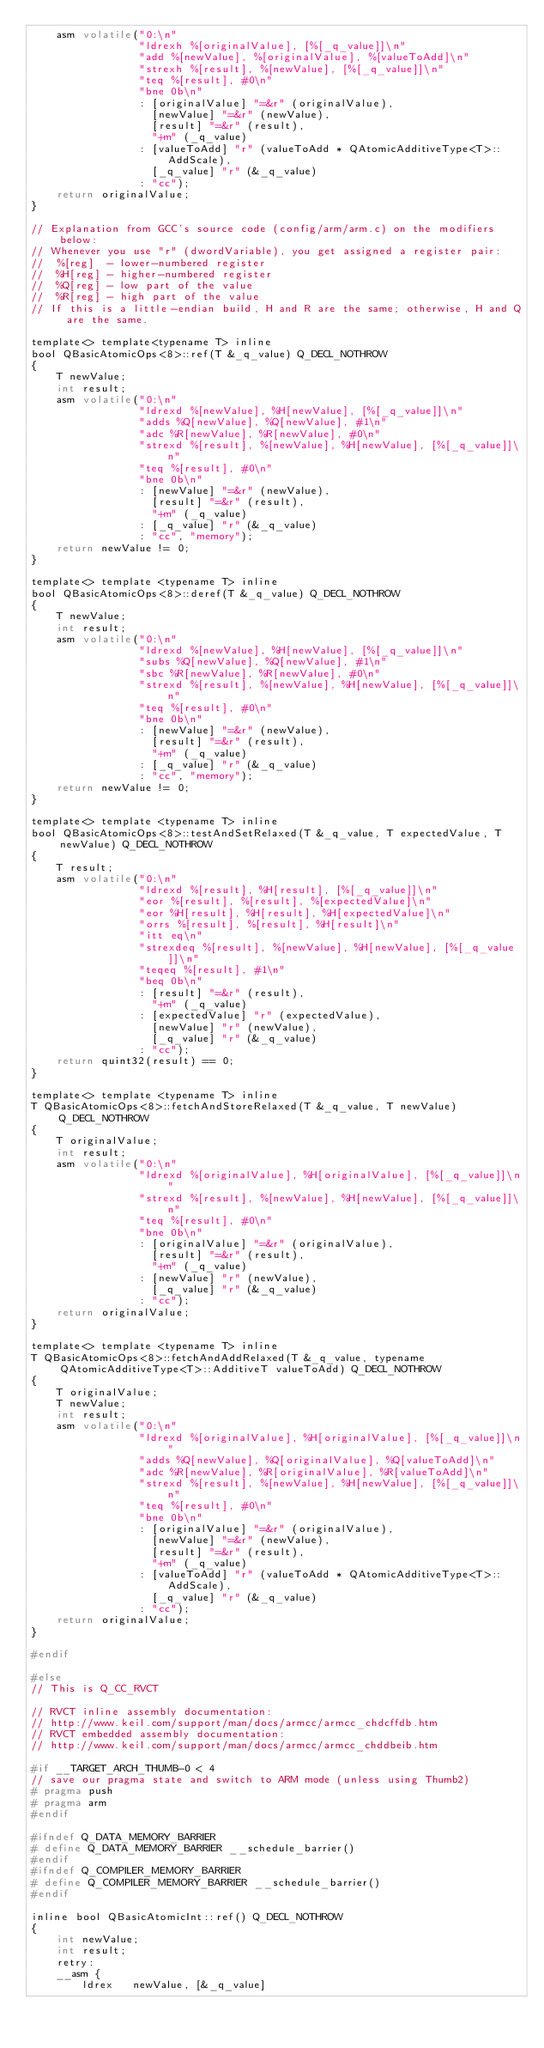Convert code to text. <code><loc_0><loc_0><loc_500><loc_500><_C_>    asm volatile("0:\n"
                 "ldrexh %[originalValue], [%[_q_value]]\n"
                 "add %[newValue], %[originalValue], %[valueToAdd]\n"
                 "strexh %[result], %[newValue], [%[_q_value]]\n"
                 "teq %[result], #0\n"
                 "bne 0b\n"
                 : [originalValue] "=&r" (originalValue),
                   [newValue] "=&r" (newValue),
                   [result] "=&r" (result),
                   "+m" (_q_value)
                 : [valueToAdd] "r" (valueToAdd * QAtomicAdditiveType<T>::AddScale),
                   [_q_value] "r" (&_q_value)
                 : "cc");
    return originalValue;
}

// Explanation from GCC's source code (config/arm/arm.c) on the modifiers below:
// Whenever you use "r" (dwordVariable), you get assigned a register pair:
//  %[reg]  - lower-numbered register
//  %H[reg] - higher-numbered register
//  %Q[reg] - low part of the value
//  %R[reg] - high part of the value
// If this is a little-endian build, H and R are the same; otherwise, H and Q are the same.

template<> template<typename T> inline
bool QBasicAtomicOps<8>::ref(T &_q_value) Q_DECL_NOTHROW
{
    T newValue;
    int result;
    asm volatile("0:\n"
                 "ldrexd %[newValue], %H[newValue], [%[_q_value]]\n"
                 "adds %Q[newValue], %Q[newValue], #1\n"
                 "adc %R[newValue], %R[newValue], #0\n"
                 "strexd %[result], %[newValue], %H[newValue], [%[_q_value]]\n"
                 "teq %[result], #0\n"
                 "bne 0b\n"
                 : [newValue] "=&r" (newValue),
                   [result] "=&r" (result),
                   "+m" (_q_value)
                 : [_q_value] "r" (&_q_value)
                 : "cc", "memory");
    return newValue != 0;
}

template<> template <typename T> inline
bool QBasicAtomicOps<8>::deref(T &_q_value) Q_DECL_NOTHROW
{
    T newValue;
    int result;
    asm volatile("0:\n"
                 "ldrexd %[newValue], %H[newValue], [%[_q_value]]\n"
                 "subs %Q[newValue], %Q[newValue], #1\n"
                 "sbc %R[newValue], %R[newValue], #0\n"
                 "strexd %[result], %[newValue], %H[newValue], [%[_q_value]]\n"
                 "teq %[result], #0\n"
                 "bne 0b\n"
                 : [newValue] "=&r" (newValue),
                   [result] "=&r" (result),
                   "+m" (_q_value)
                 : [_q_value] "r" (&_q_value)
                 : "cc", "memory");
    return newValue != 0;
}

template<> template <typename T> inline
bool QBasicAtomicOps<8>::testAndSetRelaxed(T &_q_value, T expectedValue, T newValue) Q_DECL_NOTHROW
{
    T result;
    asm volatile("0:\n"
                 "ldrexd %[result], %H[result], [%[_q_value]]\n"
                 "eor %[result], %[result], %[expectedValue]\n"
                 "eor %H[result], %H[result], %H[expectedValue]\n"
                 "orrs %[result], %[result], %H[result]\n"
                 "itt eq\n"
                 "strexdeq %[result], %[newValue], %H[newValue], [%[_q_value]]\n"
                 "teqeq %[result], #1\n"
                 "beq 0b\n"
                 : [result] "=&r" (result),
                   "+m" (_q_value)
                 : [expectedValue] "r" (expectedValue),
                   [newValue] "r" (newValue),
                   [_q_value] "r" (&_q_value)
                 : "cc");
    return quint32(result) == 0;
}

template<> template <typename T> inline
T QBasicAtomicOps<8>::fetchAndStoreRelaxed(T &_q_value, T newValue) Q_DECL_NOTHROW
{
    T originalValue;
    int result;
    asm volatile("0:\n"
                 "ldrexd %[originalValue], %H[originalValue], [%[_q_value]]\n"
                 "strexd %[result], %[newValue], %H[newValue], [%[_q_value]]\n"
                 "teq %[result], #0\n"
                 "bne 0b\n"
                 : [originalValue] "=&r" (originalValue),
                   [result] "=&r" (result),
                   "+m" (_q_value)
                 : [newValue] "r" (newValue),
                   [_q_value] "r" (&_q_value)
                 : "cc");
    return originalValue;
}

template<> template <typename T> inline
T QBasicAtomicOps<8>::fetchAndAddRelaxed(T &_q_value, typename QAtomicAdditiveType<T>::AdditiveT valueToAdd) Q_DECL_NOTHROW
{
    T originalValue;
    T newValue;
    int result;
    asm volatile("0:\n"
                 "ldrexd %[originalValue], %H[originalValue], [%[_q_value]]\n"
                 "adds %Q[newValue], %Q[originalValue], %Q[valueToAdd]\n"
                 "adc %R[newValue], %R[originalValue], %R[valueToAdd]\n"
                 "strexd %[result], %[newValue], %H[newValue], [%[_q_value]]\n"
                 "teq %[result], #0\n"
                 "bne 0b\n"
                 : [originalValue] "=&r" (originalValue),
                   [newValue] "=&r" (newValue),
                   [result] "=&r" (result),
                   "+m" (_q_value)
                 : [valueToAdd] "r" (valueToAdd * QAtomicAdditiveType<T>::AddScale),
                   [_q_value] "r" (&_q_value)
                 : "cc");
    return originalValue;
}

#endif

#else
// This is Q_CC_RVCT

// RVCT inline assembly documentation:
// http://www.keil.com/support/man/docs/armcc/armcc_chdcffdb.htm
// RVCT embedded assembly documentation:
// http://www.keil.com/support/man/docs/armcc/armcc_chddbeib.htm

#if __TARGET_ARCH_THUMB-0 < 4
// save our pragma state and switch to ARM mode (unless using Thumb2)
# pragma push
# pragma arm
#endif

#ifndef Q_DATA_MEMORY_BARRIER
# define Q_DATA_MEMORY_BARRIER __schedule_barrier()
#endif
#ifndef Q_COMPILER_MEMORY_BARRIER
# define Q_COMPILER_MEMORY_BARRIER __schedule_barrier()
#endif

inline bool QBasicAtomicInt::ref() Q_DECL_NOTHROW
{
    int newValue;
    int result;
    retry:
    __asm {
        ldrex   newValue, [&_q_value]</code> 